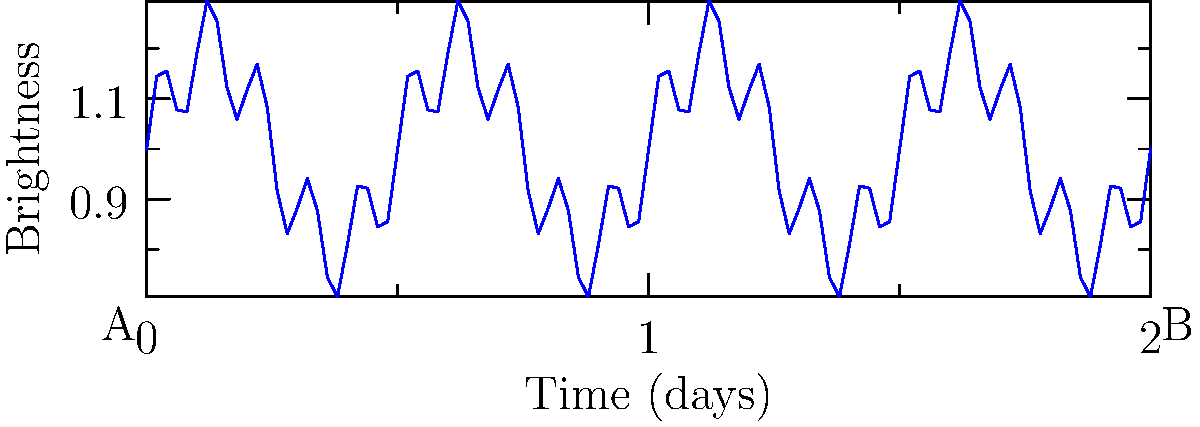As a market researcher analyzing astronomical data, you encounter a light curve of a variable star. The graph shows the star's brightness over time. What type of variability does this light curve suggest, and how might this information be stored efficiently in a database for large-scale analysis? To interpret this light curve and determine the star's variability:

1. Observe the overall pattern: The brightness shows regular, periodic fluctuations.

2. Identify components:
   a) A long-term variation with a period of about 0.5 days.
   b) A short-term variation superimposed on the longer cycle.

3. Classify variability: This pattern suggests a multi-periodic variable star, possibly a:
   - Delta Scuti star (short-period pulsating variable)
   - RR Lyrae star (pulsating variable with multiple modes)

4. Database storage considerations:
   a) Store raw time series data in a table with columns:
      - Star ID (primary key)
      - Timestamp
      - Brightness value

   b) Create a separate table for derived characteristics:
      - Star ID (foreign key)
      - Primary period
      - Secondary period
      - Amplitude of primary variation
      - Amplitude of secondary variation
      - Variability type classification

5. Indexing: Create indexes on Star ID and Timestamp for efficient querying.

6. Partitioning: For very large datasets, consider partitioning the data by time ranges or star characteristics.

7. Compression: Use appropriate compression techniques for time series data to optimize storage.

This structure allows for efficient storage and retrieval of both raw data and derived characteristics, facilitating large-scale analysis of variable star populations.
Answer: Multi-periodic variable star; store time series in one table, derived characteristics in another, with appropriate indexing and partitioning. 